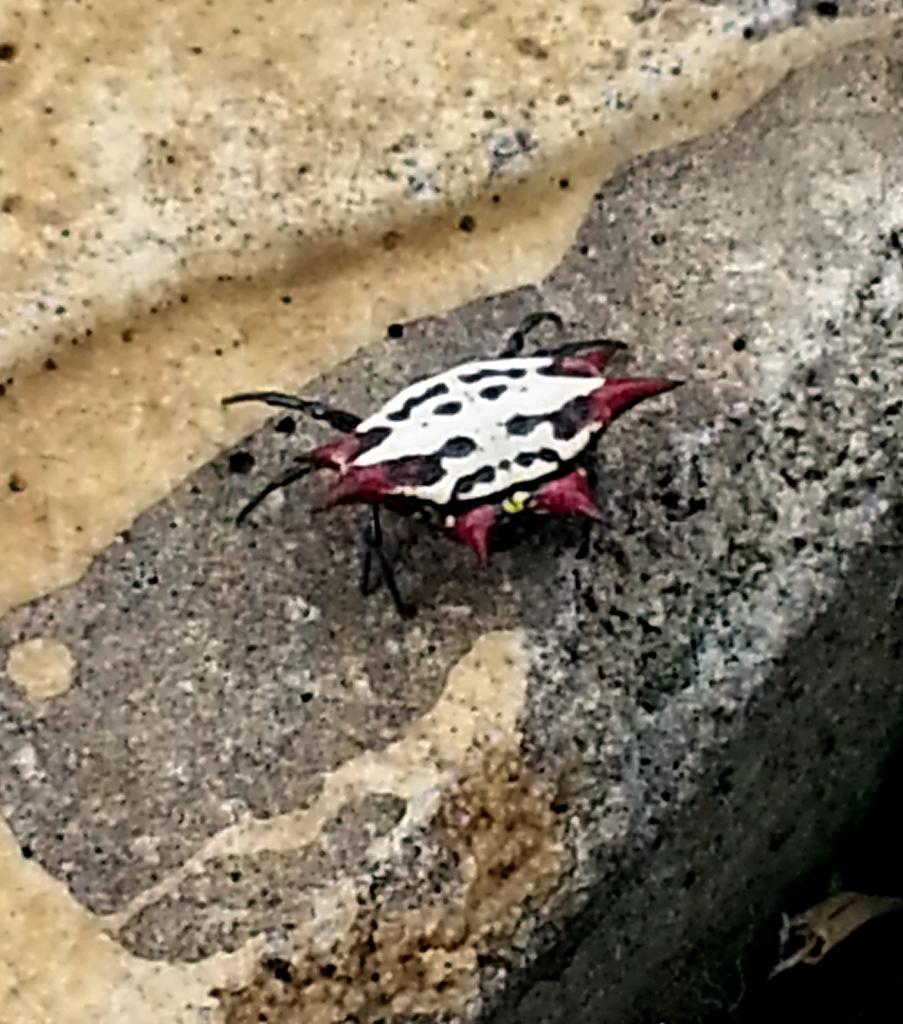Please provide a concise description of this image. This picture shows a Insect on the floor. 